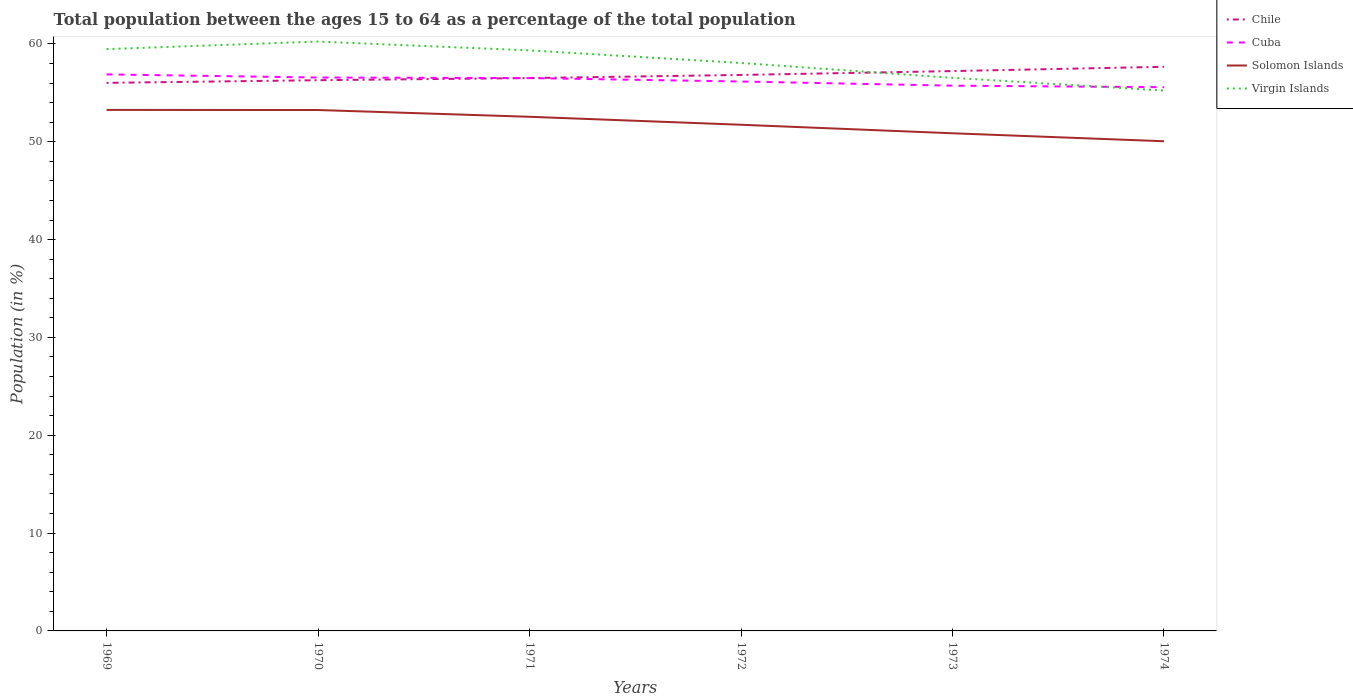How many different coloured lines are there?
Make the answer very short. 4. Across all years, what is the maximum percentage of the population ages 15 to 64 in Virgin Islands?
Keep it short and to the point. 55.23. In which year was the percentage of the population ages 15 to 64 in Cuba maximum?
Give a very brief answer. 1974. What is the total percentage of the population ages 15 to 64 in Virgin Islands in the graph?
Provide a succinct answer. -0.77. What is the difference between the highest and the second highest percentage of the population ages 15 to 64 in Solomon Islands?
Give a very brief answer. 3.2. Is the percentage of the population ages 15 to 64 in Cuba strictly greater than the percentage of the population ages 15 to 64 in Chile over the years?
Your answer should be very brief. No. How many years are there in the graph?
Offer a very short reply. 6. What is the difference between two consecutive major ticks on the Y-axis?
Your answer should be very brief. 10. Are the values on the major ticks of Y-axis written in scientific E-notation?
Provide a short and direct response. No. Does the graph contain any zero values?
Your answer should be compact. No. Does the graph contain grids?
Ensure brevity in your answer.  No. How are the legend labels stacked?
Your answer should be compact. Vertical. What is the title of the graph?
Your response must be concise. Total population between the ages 15 to 64 as a percentage of the total population. Does "Macao" appear as one of the legend labels in the graph?
Your answer should be compact. No. What is the Population (in %) of Chile in 1969?
Make the answer very short. 56.02. What is the Population (in %) of Cuba in 1969?
Keep it short and to the point. 56.88. What is the Population (in %) in Solomon Islands in 1969?
Provide a succinct answer. 53.25. What is the Population (in %) of Virgin Islands in 1969?
Give a very brief answer. 59.46. What is the Population (in %) in Chile in 1970?
Your response must be concise. 56.29. What is the Population (in %) in Cuba in 1970?
Your answer should be compact. 56.56. What is the Population (in %) of Solomon Islands in 1970?
Provide a short and direct response. 53.24. What is the Population (in %) in Virgin Islands in 1970?
Make the answer very short. 60.24. What is the Population (in %) of Chile in 1971?
Offer a very short reply. 56.51. What is the Population (in %) of Cuba in 1971?
Your answer should be compact. 56.51. What is the Population (in %) of Solomon Islands in 1971?
Your answer should be very brief. 52.55. What is the Population (in %) of Virgin Islands in 1971?
Provide a succinct answer. 59.34. What is the Population (in %) in Chile in 1972?
Offer a very short reply. 56.83. What is the Population (in %) in Cuba in 1972?
Offer a terse response. 56.16. What is the Population (in %) of Solomon Islands in 1972?
Keep it short and to the point. 51.74. What is the Population (in %) in Virgin Islands in 1972?
Your answer should be very brief. 58.05. What is the Population (in %) of Chile in 1973?
Your answer should be compact. 57.22. What is the Population (in %) in Cuba in 1973?
Ensure brevity in your answer.  55.73. What is the Population (in %) in Solomon Islands in 1973?
Offer a terse response. 50.86. What is the Population (in %) in Virgin Islands in 1973?
Provide a succinct answer. 56.53. What is the Population (in %) in Chile in 1974?
Provide a succinct answer. 57.66. What is the Population (in %) in Cuba in 1974?
Give a very brief answer. 55.57. What is the Population (in %) of Solomon Islands in 1974?
Offer a very short reply. 50.05. What is the Population (in %) of Virgin Islands in 1974?
Make the answer very short. 55.23. Across all years, what is the maximum Population (in %) of Chile?
Your answer should be compact. 57.66. Across all years, what is the maximum Population (in %) in Cuba?
Provide a short and direct response. 56.88. Across all years, what is the maximum Population (in %) of Solomon Islands?
Keep it short and to the point. 53.25. Across all years, what is the maximum Population (in %) in Virgin Islands?
Keep it short and to the point. 60.24. Across all years, what is the minimum Population (in %) in Chile?
Offer a terse response. 56.02. Across all years, what is the minimum Population (in %) of Cuba?
Provide a succinct answer. 55.57. Across all years, what is the minimum Population (in %) in Solomon Islands?
Your response must be concise. 50.05. Across all years, what is the minimum Population (in %) in Virgin Islands?
Provide a succinct answer. 55.23. What is the total Population (in %) in Chile in the graph?
Provide a succinct answer. 340.52. What is the total Population (in %) in Cuba in the graph?
Keep it short and to the point. 337.41. What is the total Population (in %) of Solomon Islands in the graph?
Provide a short and direct response. 311.7. What is the total Population (in %) in Virgin Islands in the graph?
Offer a very short reply. 348.86. What is the difference between the Population (in %) of Chile in 1969 and that in 1970?
Provide a short and direct response. -0.27. What is the difference between the Population (in %) of Cuba in 1969 and that in 1970?
Offer a very short reply. 0.32. What is the difference between the Population (in %) in Solomon Islands in 1969 and that in 1970?
Your answer should be very brief. 0.01. What is the difference between the Population (in %) of Virgin Islands in 1969 and that in 1970?
Offer a very short reply. -0.77. What is the difference between the Population (in %) of Chile in 1969 and that in 1971?
Offer a terse response. -0.49. What is the difference between the Population (in %) in Cuba in 1969 and that in 1971?
Give a very brief answer. 0.38. What is the difference between the Population (in %) of Solomon Islands in 1969 and that in 1971?
Your response must be concise. 0.7. What is the difference between the Population (in %) in Virgin Islands in 1969 and that in 1971?
Your answer should be compact. 0.13. What is the difference between the Population (in %) in Chile in 1969 and that in 1972?
Your answer should be very brief. -0.81. What is the difference between the Population (in %) in Cuba in 1969 and that in 1972?
Your response must be concise. 0.72. What is the difference between the Population (in %) of Solomon Islands in 1969 and that in 1972?
Your answer should be very brief. 1.52. What is the difference between the Population (in %) in Virgin Islands in 1969 and that in 1972?
Offer a terse response. 1.41. What is the difference between the Population (in %) in Chile in 1969 and that in 1973?
Offer a very short reply. -1.2. What is the difference between the Population (in %) of Cuba in 1969 and that in 1973?
Your answer should be compact. 1.15. What is the difference between the Population (in %) in Solomon Islands in 1969 and that in 1973?
Provide a succinct answer. 2.39. What is the difference between the Population (in %) in Virgin Islands in 1969 and that in 1973?
Your response must be concise. 2.93. What is the difference between the Population (in %) in Chile in 1969 and that in 1974?
Your answer should be compact. -1.64. What is the difference between the Population (in %) in Cuba in 1969 and that in 1974?
Your answer should be very brief. 1.31. What is the difference between the Population (in %) of Solomon Islands in 1969 and that in 1974?
Your answer should be compact. 3.2. What is the difference between the Population (in %) of Virgin Islands in 1969 and that in 1974?
Ensure brevity in your answer.  4.23. What is the difference between the Population (in %) in Chile in 1970 and that in 1971?
Your answer should be very brief. -0.22. What is the difference between the Population (in %) in Cuba in 1970 and that in 1971?
Provide a short and direct response. 0.06. What is the difference between the Population (in %) in Solomon Islands in 1970 and that in 1971?
Ensure brevity in your answer.  0.69. What is the difference between the Population (in %) in Virgin Islands in 1970 and that in 1971?
Offer a terse response. 0.9. What is the difference between the Population (in %) of Chile in 1970 and that in 1972?
Your answer should be very brief. -0.54. What is the difference between the Population (in %) of Cuba in 1970 and that in 1972?
Your answer should be compact. 0.41. What is the difference between the Population (in %) of Solomon Islands in 1970 and that in 1972?
Your response must be concise. 1.51. What is the difference between the Population (in %) in Virgin Islands in 1970 and that in 1972?
Provide a short and direct response. 2.19. What is the difference between the Population (in %) in Chile in 1970 and that in 1973?
Provide a succinct answer. -0.93. What is the difference between the Population (in %) of Cuba in 1970 and that in 1973?
Provide a short and direct response. 0.83. What is the difference between the Population (in %) of Solomon Islands in 1970 and that in 1973?
Provide a short and direct response. 2.38. What is the difference between the Population (in %) of Virgin Islands in 1970 and that in 1973?
Keep it short and to the point. 3.71. What is the difference between the Population (in %) of Chile in 1970 and that in 1974?
Your response must be concise. -1.37. What is the difference between the Population (in %) of Solomon Islands in 1970 and that in 1974?
Provide a short and direct response. 3.19. What is the difference between the Population (in %) of Virgin Islands in 1970 and that in 1974?
Give a very brief answer. 5. What is the difference between the Population (in %) of Chile in 1971 and that in 1972?
Provide a short and direct response. -0.32. What is the difference between the Population (in %) of Cuba in 1971 and that in 1972?
Provide a succinct answer. 0.35. What is the difference between the Population (in %) in Solomon Islands in 1971 and that in 1972?
Your answer should be very brief. 0.82. What is the difference between the Population (in %) of Virgin Islands in 1971 and that in 1972?
Provide a succinct answer. 1.29. What is the difference between the Population (in %) of Chile in 1971 and that in 1973?
Provide a short and direct response. -0.71. What is the difference between the Population (in %) in Cuba in 1971 and that in 1973?
Keep it short and to the point. 0.77. What is the difference between the Population (in %) in Solomon Islands in 1971 and that in 1973?
Give a very brief answer. 1.69. What is the difference between the Population (in %) of Virgin Islands in 1971 and that in 1973?
Ensure brevity in your answer.  2.81. What is the difference between the Population (in %) of Chile in 1971 and that in 1974?
Your answer should be compact. -1.15. What is the difference between the Population (in %) in Cuba in 1971 and that in 1974?
Your answer should be compact. 0.93. What is the difference between the Population (in %) of Solomon Islands in 1971 and that in 1974?
Offer a terse response. 2.5. What is the difference between the Population (in %) of Virgin Islands in 1971 and that in 1974?
Offer a terse response. 4.1. What is the difference between the Population (in %) in Chile in 1972 and that in 1973?
Offer a very short reply. -0.39. What is the difference between the Population (in %) in Cuba in 1972 and that in 1973?
Provide a succinct answer. 0.42. What is the difference between the Population (in %) of Solomon Islands in 1972 and that in 1973?
Offer a terse response. 0.87. What is the difference between the Population (in %) of Virgin Islands in 1972 and that in 1973?
Ensure brevity in your answer.  1.52. What is the difference between the Population (in %) in Chile in 1972 and that in 1974?
Offer a very short reply. -0.83. What is the difference between the Population (in %) in Cuba in 1972 and that in 1974?
Your answer should be compact. 0.58. What is the difference between the Population (in %) in Solomon Islands in 1972 and that in 1974?
Offer a very short reply. 1.69. What is the difference between the Population (in %) in Virgin Islands in 1972 and that in 1974?
Provide a succinct answer. 2.82. What is the difference between the Population (in %) in Chile in 1973 and that in 1974?
Provide a succinct answer. -0.44. What is the difference between the Population (in %) in Cuba in 1973 and that in 1974?
Give a very brief answer. 0.16. What is the difference between the Population (in %) of Solomon Islands in 1973 and that in 1974?
Your answer should be compact. 0.82. What is the difference between the Population (in %) in Virgin Islands in 1973 and that in 1974?
Offer a very short reply. 1.3. What is the difference between the Population (in %) in Chile in 1969 and the Population (in %) in Cuba in 1970?
Provide a succinct answer. -0.54. What is the difference between the Population (in %) of Chile in 1969 and the Population (in %) of Solomon Islands in 1970?
Offer a very short reply. 2.78. What is the difference between the Population (in %) of Chile in 1969 and the Population (in %) of Virgin Islands in 1970?
Provide a succinct answer. -4.22. What is the difference between the Population (in %) of Cuba in 1969 and the Population (in %) of Solomon Islands in 1970?
Give a very brief answer. 3.64. What is the difference between the Population (in %) in Cuba in 1969 and the Population (in %) in Virgin Islands in 1970?
Provide a succinct answer. -3.36. What is the difference between the Population (in %) in Solomon Islands in 1969 and the Population (in %) in Virgin Islands in 1970?
Offer a terse response. -6.99. What is the difference between the Population (in %) in Chile in 1969 and the Population (in %) in Cuba in 1971?
Your answer should be very brief. -0.49. What is the difference between the Population (in %) of Chile in 1969 and the Population (in %) of Solomon Islands in 1971?
Ensure brevity in your answer.  3.47. What is the difference between the Population (in %) in Chile in 1969 and the Population (in %) in Virgin Islands in 1971?
Your answer should be very brief. -3.32. What is the difference between the Population (in %) in Cuba in 1969 and the Population (in %) in Solomon Islands in 1971?
Offer a very short reply. 4.33. What is the difference between the Population (in %) in Cuba in 1969 and the Population (in %) in Virgin Islands in 1971?
Ensure brevity in your answer.  -2.46. What is the difference between the Population (in %) in Solomon Islands in 1969 and the Population (in %) in Virgin Islands in 1971?
Make the answer very short. -6.08. What is the difference between the Population (in %) in Chile in 1969 and the Population (in %) in Cuba in 1972?
Your answer should be very brief. -0.14. What is the difference between the Population (in %) in Chile in 1969 and the Population (in %) in Solomon Islands in 1972?
Give a very brief answer. 4.28. What is the difference between the Population (in %) of Chile in 1969 and the Population (in %) of Virgin Islands in 1972?
Provide a succinct answer. -2.03. What is the difference between the Population (in %) of Cuba in 1969 and the Population (in %) of Solomon Islands in 1972?
Keep it short and to the point. 5.15. What is the difference between the Population (in %) in Cuba in 1969 and the Population (in %) in Virgin Islands in 1972?
Offer a terse response. -1.17. What is the difference between the Population (in %) of Solomon Islands in 1969 and the Population (in %) of Virgin Islands in 1972?
Your response must be concise. -4.8. What is the difference between the Population (in %) of Chile in 1969 and the Population (in %) of Cuba in 1973?
Make the answer very short. 0.29. What is the difference between the Population (in %) in Chile in 1969 and the Population (in %) in Solomon Islands in 1973?
Make the answer very short. 5.15. What is the difference between the Population (in %) of Chile in 1969 and the Population (in %) of Virgin Islands in 1973?
Keep it short and to the point. -0.51. What is the difference between the Population (in %) of Cuba in 1969 and the Population (in %) of Solomon Islands in 1973?
Keep it short and to the point. 6.02. What is the difference between the Population (in %) of Cuba in 1969 and the Population (in %) of Virgin Islands in 1973?
Make the answer very short. 0.35. What is the difference between the Population (in %) in Solomon Islands in 1969 and the Population (in %) in Virgin Islands in 1973?
Keep it short and to the point. -3.28. What is the difference between the Population (in %) of Chile in 1969 and the Population (in %) of Cuba in 1974?
Give a very brief answer. 0.44. What is the difference between the Population (in %) in Chile in 1969 and the Population (in %) in Solomon Islands in 1974?
Offer a terse response. 5.97. What is the difference between the Population (in %) in Chile in 1969 and the Population (in %) in Virgin Islands in 1974?
Keep it short and to the point. 0.78. What is the difference between the Population (in %) of Cuba in 1969 and the Population (in %) of Solomon Islands in 1974?
Your answer should be compact. 6.83. What is the difference between the Population (in %) of Cuba in 1969 and the Population (in %) of Virgin Islands in 1974?
Provide a short and direct response. 1.65. What is the difference between the Population (in %) in Solomon Islands in 1969 and the Population (in %) in Virgin Islands in 1974?
Give a very brief answer. -1.98. What is the difference between the Population (in %) in Chile in 1970 and the Population (in %) in Cuba in 1971?
Provide a succinct answer. -0.22. What is the difference between the Population (in %) in Chile in 1970 and the Population (in %) in Solomon Islands in 1971?
Offer a terse response. 3.74. What is the difference between the Population (in %) in Chile in 1970 and the Population (in %) in Virgin Islands in 1971?
Your answer should be very brief. -3.05. What is the difference between the Population (in %) in Cuba in 1970 and the Population (in %) in Solomon Islands in 1971?
Provide a succinct answer. 4.01. What is the difference between the Population (in %) of Cuba in 1970 and the Population (in %) of Virgin Islands in 1971?
Your answer should be compact. -2.78. What is the difference between the Population (in %) of Solomon Islands in 1970 and the Population (in %) of Virgin Islands in 1971?
Offer a terse response. -6.1. What is the difference between the Population (in %) of Chile in 1970 and the Population (in %) of Cuba in 1972?
Your answer should be compact. 0.13. What is the difference between the Population (in %) of Chile in 1970 and the Population (in %) of Solomon Islands in 1972?
Offer a terse response. 4.55. What is the difference between the Population (in %) in Chile in 1970 and the Population (in %) in Virgin Islands in 1972?
Provide a short and direct response. -1.76. What is the difference between the Population (in %) of Cuba in 1970 and the Population (in %) of Solomon Islands in 1972?
Provide a short and direct response. 4.83. What is the difference between the Population (in %) of Cuba in 1970 and the Population (in %) of Virgin Islands in 1972?
Offer a terse response. -1.49. What is the difference between the Population (in %) in Solomon Islands in 1970 and the Population (in %) in Virgin Islands in 1972?
Ensure brevity in your answer.  -4.81. What is the difference between the Population (in %) of Chile in 1970 and the Population (in %) of Cuba in 1973?
Your response must be concise. 0.56. What is the difference between the Population (in %) in Chile in 1970 and the Population (in %) in Solomon Islands in 1973?
Your response must be concise. 5.42. What is the difference between the Population (in %) in Chile in 1970 and the Population (in %) in Virgin Islands in 1973?
Offer a terse response. -0.24. What is the difference between the Population (in %) of Cuba in 1970 and the Population (in %) of Solomon Islands in 1973?
Give a very brief answer. 5.7. What is the difference between the Population (in %) of Cuba in 1970 and the Population (in %) of Virgin Islands in 1973?
Offer a very short reply. 0.03. What is the difference between the Population (in %) in Solomon Islands in 1970 and the Population (in %) in Virgin Islands in 1973?
Your answer should be very brief. -3.29. What is the difference between the Population (in %) of Chile in 1970 and the Population (in %) of Cuba in 1974?
Give a very brief answer. 0.72. What is the difference between the Population (in %) in Chile in 1970 and the Population (in %) in Solomon Islands in 1974?
Provide a succinct answer. 6.24. What is the difference between the Population (in %) in Chile in 1970 and the Population (in %) in Virgin Islands in 1974?
Offer a terse response. 1.05. What is the difference between the Population (in %) in Cuba in 1970 and the Population (in %) in Solomon Islands in 1974?
Offer a terse response. 6.51. What is the difference between the Population (in %) of Cuba in 1970 and the Population (in %) of Virgin Islands in 1974?
Your answer should be compact. 1.33. What is the difference between the Population (in %) in Solomon Islands in 1970 and the Population (in %) in Virgin Islands in 1974?
Make the answer very short. -1.99. What is the difference between the Population (in %) of Chile in 1971 and the Population (in %) of Cuba in 1972?
Your answer should be compact. 0.35. What is the difference between the Population (in %) in Chile in 1971 and the Population (in %) in Solomon Islands in 1972?
Ensure brevity in your answer.  4.77. What is the difference between the Population (in %) in Chile in 1971 and the Population (in %) in Virgin Islands in 1972?
Provide a short and direct response. -1.54. What is the difference between the Population (in %) of Cuba in 1971 and the Population (in %) of Solomon Islands in 1972?
Your answer should be very brief. 4.77. What is the difference between the Population (in %) of Cuba in 1971 and the Population (in %) of Virgin Islands in 1972?
Your response must be concise. -1.54. What is the difference between the Population (in %) of Solomon Islands in 1971 and the Population (in %) of Virgin Islands in 1972?
Your response must be concise. -5.5. What is the difference between the Population (in %) of Chile in 1971 and the Population (in %) of Cuba in 1973?
Your response must be concise. 0.78. What is the difference between the Population (in %) in Chile in 1971 and the Population (in %) in Solomon Islands in 1973?
Offer a very short reply. 5.64. What is the difference between the Population (in %) in Chile in 1971 and the Population (in %) in Virgin Islands in 1973?
Offer a terse response. -0.02. What is the difference between the Population (in %) in Cuba in 1971 and the Population (in %) in Solomon Islands in 1973?
Keep it short and to the point. 5.64. What is the difference between the Population (in %) in Cuba in 1971 and the Population (in %) in Virgin Islands in 1973?
Give a very brief answer. -0.03. What is the difference between the Population (in %) of Solomon Islands in 1971 and the Population (in %) of Virgin Islands in 1973?
Your answer should be very brief. -3.98. What is the difference between the Population (in %) of Chile in 1971 and the Population (in %) of Cuba in 1974?
Your answer should be very brief. 0.93. What is the difference between the Population (in %) in Chile in 1971 and the Population (in %) in Solomon Islands in 1974?
Give a very brief answer. 6.46. What is the difference between the Population (in %) of Chile in 1971 and the Population (in %) of Virgin Islands in 1974?
Your response must be concise. 1.27. What is the difference between the Population (in %) in Cuba in 1971 and the Population (in %) in Solomon Islands in 1974?
Offer a very short reply. 6.46. What is the difference between the Population (in %) of Cuba in 1971 and the Population (in %) of Virgin Islands in 1974?
Provide a short and direct response. 1.27. What is the difference between the Population (in %) of Solomon Islands in 1971 and the Population (in %) of Virgin Islands in 1974?
Keep it short and to the point. -2.68. What is the difference between the Population (in %) in Chile in 1972 and the Population (in %) in Cuba in 1973?
Ensure brevity in your answer.  1.09. What is the difference between the Population (in %) in Chile in 1972 and the Population (in %) in Solomon Islands in 1973?
Offer a terse response. 5.96. What is the difference between the Population (in %) in Chile in 1972 and the Population (in %) in Virgin Islands in 1973?
Give a very brief answer. 0.3. What is the difference between the Population (in %) of Cuba in 1972 and the Population (in %) of Solomon Islands in 1973?
Provide a succinct answer. 5.29. What is the difference between the Population (in %) of Cuba in 1972 and the Population (in %) of Virgin Islands in 1973?
Your answer should be compact. -0.38. What is the difference between the Population (in %) in Solomon Islands in 1972 and the Population (in %) in Virgin Islands in 1973?
Keep it short and to the point. -4.8. What is the difference between the Population (in %) of Chile in 1972 and the Population (in %) of Cuba in 1974?
Give a very brief answer. 1.25. What is the difference between the Population (in %) in Chile in 1972 and the Population (in %) in Solomon Islands in 1974?
Your answer should be very brief. 6.78. What is the difference between the Population (in %) in Chile in 1972 and the Population (in %) in Virgin Islands in 1974?
Keep it short and to the point. 1.59. What is the difference between the Population (in %) of Cuba in 1972 and the Population (in %) of Solomon Islands in 1974?
Offer a very short reply. 6.11. What is the difference between the Population (in %) in Cuba in 1972 and the Population (in %) in Virgin Islands in 1974?
Make the answer very short. 0.92. What is the difference between the Population (in %) of Solomon Islands in 1972 and the Population (in %) of Virgin Islands in 1974?
Give a very brief answer. -3.5. What is the difference between the Population (in %) in Chile in 1973 and the Population (in %) in Cuba in 1974?
Offer a very short reply. 1.65. What is the difference between the Population (in %) in Chile in 1973 and the Population (in %) in Solomon Islands in 1974?
Provide a succinct answer. 7.17. What is the difference between the Population (in %) of Chile in 1973 and the Population (in %) of Virgin Islands in 1974?
Your response must be concise. 1.99. What is the difference between the Population (in %) in Cuba in 1973 and the Population (in %) in Solomon Islands in 1974?
Offer a very short reply. 5.68. What is the difference between the Population (in %) in Cuba in 1973 and the Population (in %) in Virgin Islands in 1974?
Your answer should be compact. 0.5. What is the difference between the Population (in %) of Solomon Islands in 1973 and the Population (in %) of Virgin Islands in 1974?
Offer a very short reply. -4.37. What is the average Population (in %) in Chile per year?
Provide a succinct answer. 56.75. What is the average Population (in %) in Cuba per year?
Offer a terse response. 56.23. What is the average Population (in %) in Solomon Islands per year?
Offer a very short reply. 51.95. What is the average Population (in %) of Virgin Islands per year?
Your answer should be very brief. 58.14. In the year 1969, what is the difference between the Population (in %) in Chile and Population (in %) in Cuba?
Your answer should be very brief. -0.86. In the year 1969, what is the difference between the Population (in %) of Chile and Population (in %) of Solomon Islands?
Give a very brief answer. 2.77. In the year 1969, what is the difference between the Population (in %) in Chile and Population (in %) in Virgin Islands?
Offer a terse response. -3.45. In the year 1969, what is the difference between the Population (in %) in Cuba and Population (in %) in Solomon Islands?
Keep it short and to the point. 3.63. In the year 1969, what is the difference between the Population (in %) in Cuba and Population (in %) in Virgin Islands?
Your answer should be very brief. -2.58. In the year 1969, what is the difference between the Population (in %) in Solomon Islands and Population (in %) in Virgin Islands?
Give a very brief answer. -6.21. In the year 1970, what is the difference between the Population (in %) of Chile and Population (in %) of Cuba?
Offer a terse response. -0.27. In the year 1970, what is the difference between the Population (in %) in Chile and Population (in %) in Solomon Islands?
Keep it short and to the point. 3.05. In the year 1970, what is the difference between the Population (in %) of Chile and Population (in %) of Virgin Islands?
Give a very brief answer. -3.95. In the year 1970, what is the difference between the Population (in %) in Cuba and Population (in %) in Solomon Islands?
Make the answer very short. 3.32. In the year 1970, what is the difference between the Population (in %) of Cuba and Population (in %) of Virgin Islands?
Your answer should be compact. -3.68. In the year 1970, what is the difference between the Population (in %) in Solomon Islands and Population (in %) in Virgin Islands?
Your response must be concise. -7. In the year 1971, what is the difference between the Population (in %) of Chile and Population (in %) of Cuba?
Your response must be concise. 0. In the year 1971, what is the difference between the Population (in %) in Chile and Population (in %) in Solomon Islands?
Keep it short and to the point. 3.96. In the year 1971, what is the difference between the Population (in %) in Chile and Population (in %) in Virgin Islands?
Offer a very short reply. -2.83. In the year 1971, what is the difference between the Population (in %) of Cuba and Population (in %) of Solomon Islands?
Your answer should be compact. 3.95. In the year 1971, what is the difference between the Population (in %) in Cuba and Population (in %) in Virgin Islands?
Offer a terse response. -2.83. In the year 1971, what is the difference between the Population (in %) of Solomon Islands and Population (in %) of Virgin Islands?
Your answer should be compact. -6.79. In the year 1972, what is the difference between the Population (in %) in Chile and Population (in %) in Cuba?
Your response must be concise. 0.67. In the year 1972, what is the difference between the Population (in %) in Chile and Population (in %) in Solomon Islands?
Offer a very short reply. 5.09. In the year 1972, what is the difference between the Population (in %) in Chile and Population (in %) in Virgin Islands?
Your answer should be very brief. -1.22. In the year 1972, what is the difference between the Population (in %) in Cuba and Population (in %) in Solomon Islands?
Your answer should be compact. 4.42. In the year 1972, what is the difference between the Population (in %) in Cuba and Population (in %) in Virgin Islands?
Ensure brevity in your answer.  -1.89. In the year 1972, what is the difference between the Population (in %) in Solomon Islands and Population (in %) in Virgin Islands?
Your response must be concise. -6.31. In the year 1973, what is the difference between the Population (in %) in Chile and Population (in %) in Cuba?
Keep it short and to the point. 1.49. In the year 1973, what is the difference between the Population (in %) of Chile and Population (in %) of Solomon Islands?
Your answer should be very brief. 6.36. In the year 1973, what is the difference between the Population (in %) in Chile and Population (in %) in Virgin Islands?
Make the answer very short. 0.69. In the year 1973, what is the difference between the Population (in %) in Cuba and Population (in %) in Solomon Islands?
Provide a succinct answer. 4.87. In the year 1973, what is the difference between the Population (in %) of Cuba and Population (in %) of Virgin Islands?
Your answer should be very brief. -0.8. In the year 1973, what is the difference between the Population (in %) of Solomon Islands and Population (in %) of Virgin Islands?
Give a very brief answer. -5.67. In the year 1974, what is the difference between the Population (in %) of Chile and Population (in %) of Cuba?
Keep it short and to the point. 2.09. In the year 1974, what is the difference between the Population (in %) of Chile and Population (in %) of Solomon Islands?
Ensure brevity in your answer.  7.61. In the year 1974, what is the difference between the Population (in %) of Chile and Population (in %) of Virgin Islands?
Ensure brevity in your answer.  2.43. In the year 1974, what is the difference between the Population (in %) of Cuba and Population (in %) of Solomon Islands?
Provide a short and direct response. 5.52. In the year 1974, what is the difference between the Population (in %) of Cuba and Population (in %) of Virgin Islands?
Your answer should be very brief. 0.34. In the year 1974, what is the difference between the Population (in %) in Solomon Islands and Population (in %) in Virgin Islands?
Give a very brief answer. -5.19. What is the ratio of the Population (in %) in Solomon Islands in 1969 to that in 1970?
Your response must be concise. 1. What is the ratio of the Population (in %) of Virgin Islands in 1969 to that in 1970?
Provide a short and direct response. 0.99. What is the ratio of the Population (in %) in Cuba in 1969 to that in 1971?
Offer a very short reply. 1.01. What is the ratio of the Population (in %) of Solomon Islands in 1969 to that in 1971?
Offer a terse response. 1.01. What is the ratio of the Population (in %) in Virgin Islands in 1969 to that in 1971?
Your response must be concise. 1. What is the ratio of the Population (in %) in Chile in 1969 to that in 1972?
Your response must be concise. 0.99. What is the ratio of the Population (in %) of Cuba in 1969 to that in 1972?
Offer a very short reply. 1.01. What is the ratio of the Population (in %) of Solomon Islands in 1969 to that in 1972?
Give a very brief answer. 1.03. What is the ratio of the Population (in %) of Virgin Islands in 1969 to that in 1972?
Your response must be concise. 1.02. What is the ratio of the Population (in %) of Chile in 1969 to that in 1973?
Provide a short and direct response. 0.98. What is the ratio of the Population (in %) of Cuba in 1969 to that in 1973?
Provide a succinct answer. 1.02. What is the ratio of the Population (in %) in Solomon Islands in 1969 to that in 1973?
Your response must be concise. 1.05. What is the ratio of the Population (in %) of Virgin Islands in 1969 to that in 1973?
Make the answer very short. 1.05. What is the ratio of the Population (in %) in Chile in 1969 to that in 1974?
Provide a short and direct response. 0.97. What is the ratio of the Population (in %) of Cuba in 1969 to that in 1974?
Give a very brief answer. 1.02. What is the ratio of the Population (in %) in Solomon Islands in 1969 to that in 1974?
Your response must be concise. 1.06. What is the ratio of the Population (in %) of Virgin Islands in 1969 to that in 1974?
Provide a short and direct response. 1.08. What is the ratio of the Population (in %) of Cuba in 1970 to that in 1971?
Ensure brevity in your answer.  1. What is the ratio of the Population (in %) of Solomon Islands in 1970 to that in 1971?
Your response must be concise. 1.01. What is the ratio of the Population (in %) of Virgin Islands in 1970 to that in 1971?
Your answer should be compact. 1.02. What is the ratio of the Population (in %) of Chile in 1970 to that in 1972?
Your answer should be compact. 0.99. What is the ratio of the Population (in %) of Cuba in 1970 to that in 1972?
Your response must be concise. 1.01. What is the ratio of the Population (in %) in Solomon Islands in 1970 to that in 1972?
Provide a succinct answer. 1.03. What is the ratio of the Population (in %) of Virgin Islands in 1970 to that in 1972?
Your answer should be very brief. 1.04. What is the ratio of the Population (in %) of Chile in 1970 to that in 1973?
Provide a succinct answer. 0.98. What is the ratio of the Population (in %) in Cuba in 1970 to that in 1973?
Keep it short and to the point. 1.01. What is the ratio of the Population (in %) of Solomon Islands in 1970 to that in 1973?
Your answer should be compact. 1.05. What is the ratio of the Population (in %) in Virgin Islands in 1970 to that in 1973?
Provide a succinct answer. 1.07. What is the ratio of the Population (in %) in Chile in 1970 to that in 1974?
Give a very brief answer. 0.98. What is the ratio of the Population (in %) in Cuba in 1970 to that in 1974?
Provide a succinct answer. 1.02. What is the ratio of the Population (in %) in Solomon Islands in 1970 to that in 1974?
Keep it short and to the point. 1.06. What is the ratio of the Population (in %) in Virgin Islands in 1970 to that in 1974?
Your response must be concise. 1.09. What is the ratio of the Population (in %) of Chile in 1971 to that in 1972?
Offer a very short reply. 0.99. What is the ratio of the Population (in %) of Cuba in 1971 to that in 1972?
Offer a very short reply. 1.01. What is the ratio of the Population (in %) in Solomon Islands in 1971 to that in 1972?
Keep it short and to the point. 1.02. What is the ratio of the Population (in %) of Virgin Islands in 1971 to that in 1972?
Your answer should be compact. 1.02. What is the ratio of the Population (in %) of Chile in 1971 to that in 1973?
Your response must be concise. 0.99. What is the ratio of the Population (in %) in Cuba in 1971 to that in 1973?
Offer a very short reply. 1.01. What is the ratio of the Population (in %) in Solomon Islands in 1971 to that in 1973?
Offer a terse response. 1.03. What is the ratio of the Population (in %) in Virgin Islands in 1971 to that in 1973?
Provide a succinct answer. 1.05. What is the ratio of the Population (in %) in Chile in 1971 to that in 1974?
Ensure brevity in your answer.  0.98. What is the ratio of the Population (in %) in Cuba in 1971 to that in 1974?
Give a very brief answer. 1.02. What is the ratio of the Population (in %) of Virgin Islands in 1971 to that in 1974?
Your response must be concise. 1.07. What is the ratio of the Population (in %) of Cuba in 1972 to that in 1973?
Keep it short and to the point. 1.01. What is the ratio of the Population (in %) in Solomon Islands in 1972 to that in 1973?
Provide a succinct answer. 1.02. What is the ratio of the Population (in %) in Virgin Islands in 1972 to that in 1973?
Your answer should be compact. 1.03. What is the ratio of the Population (in %) of Chile in 1972 to that in 1974?
Provide a succinct answer. 0.99. What is the ratio of the Population (in %) of Cuba in 1972 to that in 1974?
Your answer should be compact. 1.01. What is the ratio of the Population (in %) in Solomon Islands in 1972 to that in 1974?
Your answer should be very brief. 1.03. What is the ratio of the Population (in %) of Virgin Islands in 1972 to that in 1974?
Provide a succinct answer. 1.05. What is the ratio of the Population (in %) in Solomon Islands in 1973 to that in 1974?
Your answer should be compact. 1.02. What is the ratio of the Population (in %) in Virgin Islands in 1973 to that in 1974?
Provide a short and direct response. 1.02. What is the difference between the highest and the second highest Population (in %) of Chile?
Offer a very short reply. 0.44. What is the difference between the highest and the second highest Population (in %) in Cuba?
Keep it short and to the point. 0.32. What is the difference between the highest and the second highest Population (in %) in Solomon Islands?
Offer a very short reply. 0.01. What is the difference between the highest and the second highest Population (in %) in Virgin Islands?
Your answer should be very brief. 0.77. What is the difference between the highest and the lowest Population (in %) in Chile?
Provide a short and direct response. 1.64. What is the difference between the highest and the lowest Population (in %) of Cuba?
Give a very brief answer. 1.31. What is the difference between the highest and the lowest Population (in %) in Solomon Islands?
Your answer should be very brief. 3.2. What is the difference between the highest and the lowest Population (in %) in Virgin Islands?
Provide a short and direct response. 5. 